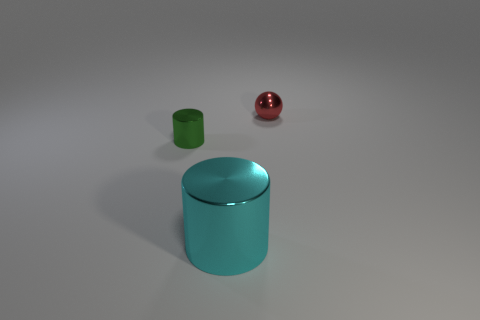What number of other objects are there of the same color as the small metallic sphere?
Keep it short and to the point. 0. The red metal object has what shape?
Your response must be concise. Sphere. How many cyan things have the same material as the sphere?
Keep it short and to the point. 1. There is another tiny thing that is the same material as the tiny green thing; what is its color?
Offer a terse response. Red. Do the cylinder that is behind the cyan thing and the sphere have the same size?
Provide a short and direct response. Yes. There is another thing that is the same shape as the tiny green thing; what is its color?
Make the answer very short. Cyan. There is a small object that is on the right side of the object that is in front of the tiny metal object that is in front of the small red shiny sphere; what shape is it?
Give a very brief answer. Sphere. Do the red object and the cyan metal thing have the same shape?
Your response must be concise. No. There is a tiny metal object behind the metal cylinder that is left of the big cyan metal cylinder; what is its shape?
Your answer should be compact. Sphere. Are any cyan metal cylinders visible?
Give a very brief answer. Yes. 